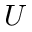<formula> <loc_0><loc_0><loc_500><loc_500>U</formula> 